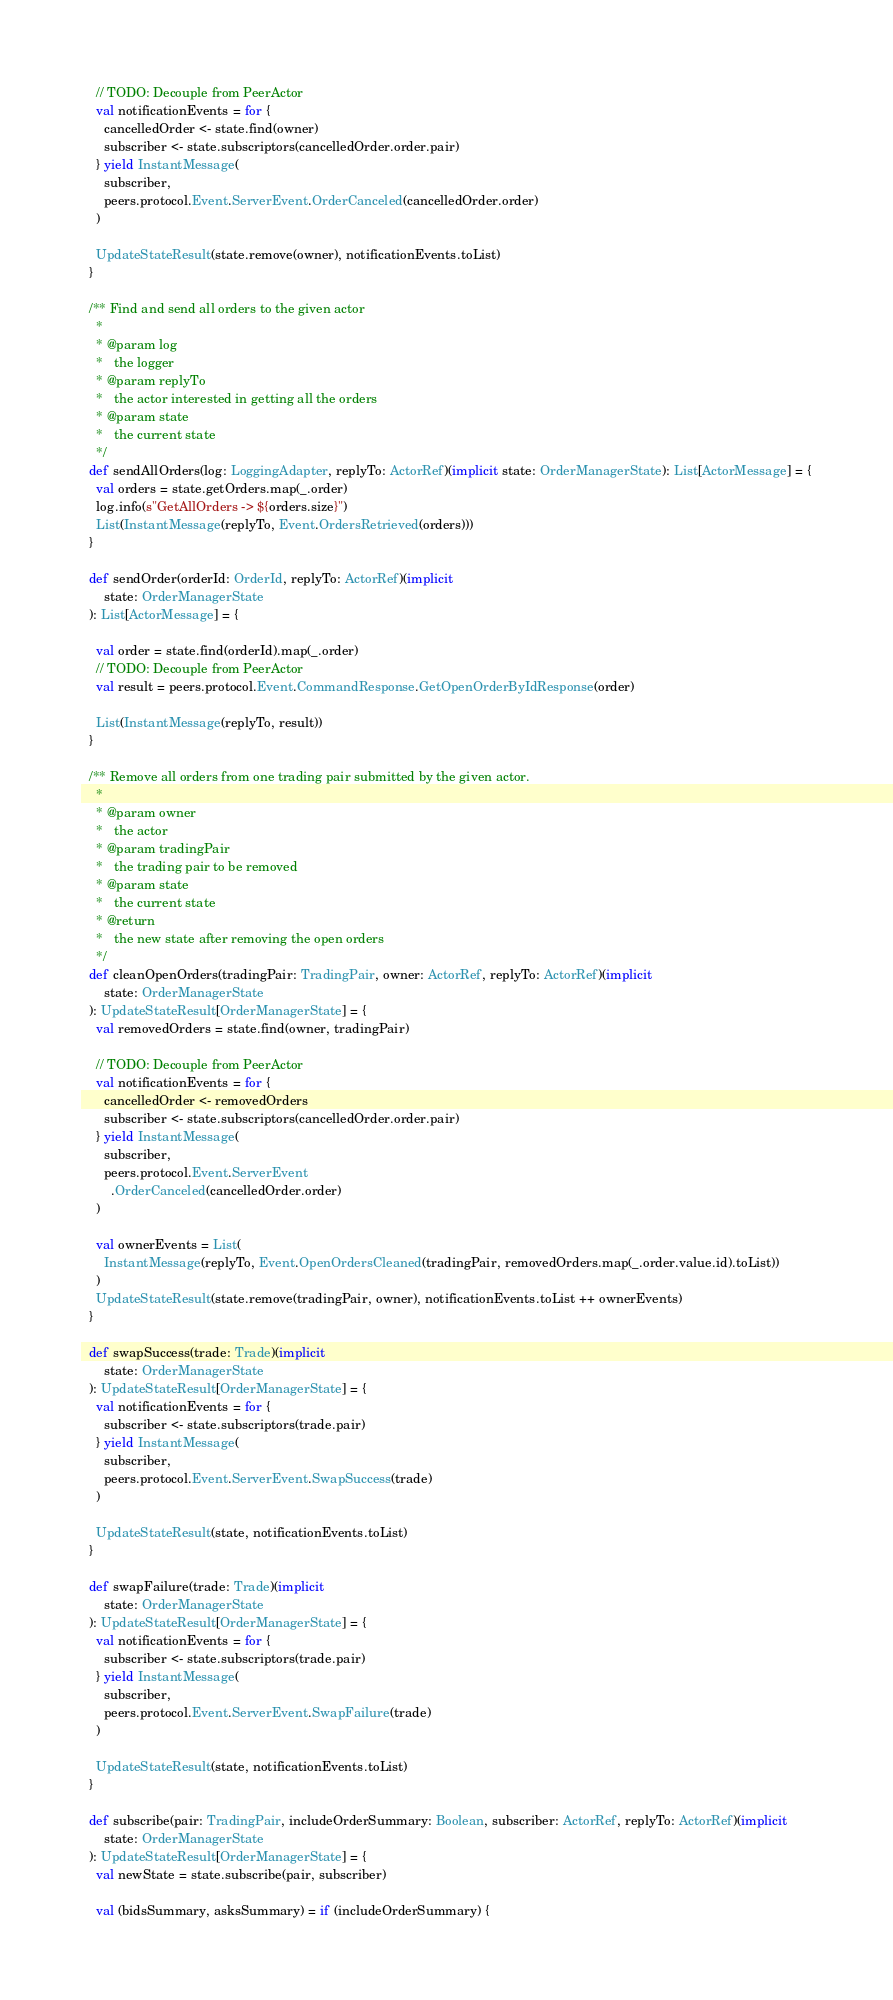<code> <loc_0><loc_0><loc_500><loc_500><_Scala_>    // TODO: Decouple from PeerActor
    val notificationEvents = for {
      cancelledOrder <- state.find(owner)
      subscriber <- state.subscriptors(cancelledOrder.order.pair)
    } yield InstantMessage(
      subscriber,
      peers.protocol.Event.ServerEvent.OrderCanceled(cancelledOrder.order)
    )

    UpdateStateResult(state.remove(owner), notificationEvents.toList)
  }

  /** Find and send all orders to the given actor
    *
    * @param log
    *   the logger
    * @param replyTo
    *   the actor interested in getting all the orders
    * @param state
    *   the current state
    */
  def sendAllOrders(log: LoggingAdapter, replyTo: ActorRef)(implicit state: OrderManagerState): List[ActorMessage] = {
    val orders = state.getOrders.map(_.order)
    log.info(s"GetAllOrders -> ${orders.size}")
    List(InstantMessage(replyTo, Event.OrdersRetrieved(orders)))
  }

  def sendOrder(orderId: OrderId, replyTo: ActorRef)(implicit
      state: OrderManagerState
  ): List[ActorMessage] = {

    val order = state.find(orderId).map(_.order)
    // TODO: Decouple from PeerActor
    val result = peers.protocol.Event.CommandResponse.GetOpenOrderByIdResponse(order)

    List(InstantMessage(replyTo, result))
  }

  /** Remove all orders from one trading pair submitted by the given actor.
    *
    * @param owner
    *   the actor
    * @param tradingPair
    *   the trading pair to be removed
    * @param state
    *   the current state
    * @return
    *   the new state after removing the open orders
    */
  def cleanOpenOrders(tradingPair: TradingPair, owner: ActorRef, replyTo: ActorRef)(implicit
      state: OrderManagerState
  ): UpdateStateResult[OrderManagerState] = {
    val removedOrders = state.find(owner, tradingPair)

    // TODO: Decouple from PeerActor
    val notificationEvents = for {
      cancelledOrder <- removedOrders
      subscriber <- state.subscriptors(cancelledOrder.order.pair)
    } yield InstantMessage(
      subscriber,
      peers.protocol.Event.ServerEvent
        .OrderCanceled(cancelledOrder.order)
    )

    val ownerEvents = List(
      InstantMessage(replyTo, Event.OpenOrdersCleaned(tradingPair, removedOrders.map(_.order.value.id).toList))
    )
    UpdateStateResult(state.remove(tradingPair, owner), notificationEvents.toList ++ ownerEvents)
  }

  def swapSuccess(trade: Trade)(implicit
      state: OrderManagerState
  ): UpdateStateResult[OrderManagerState] = {
    val notificationEvents = for {
      subscriber <- state.subscriptors(trade.pair)
    } yield InstantMessage(
      subscriber,
      peers.protocol.Event.ServerEvent.SwapSuccess(trade)
    )

    UpdateStateResult(state, notificationEvents.toList)
  }

  def swapFailure(trade: Trade)(implicit
      state: OrderManagerState
  ): UpdateStateResult[OrderManagerState] = {
    val notificationEvents = for {
      subscriber <- state.subscriptors(trade.pair)
    } yield InstantMessage(
      subscriber,
      peers.protocol.Event.ServerEvent.SwapFailure(trade)
    )

    UpdateStateResult(state, notificationEvents.toList)
  }

  def subscribe(pair: TradingPair, includeOrderSummary: Boolean, subscriber: ActorRef, replyTo: ActorRef)(implicit
      state: OrderManagerState
  ): UpdateStateResult[OrderManagerState] = {
    val newState = state.subscribe(pair, subscriber)

    val (bidsSummary, asksSummary) = if (includeOrderSummary) {</code> 